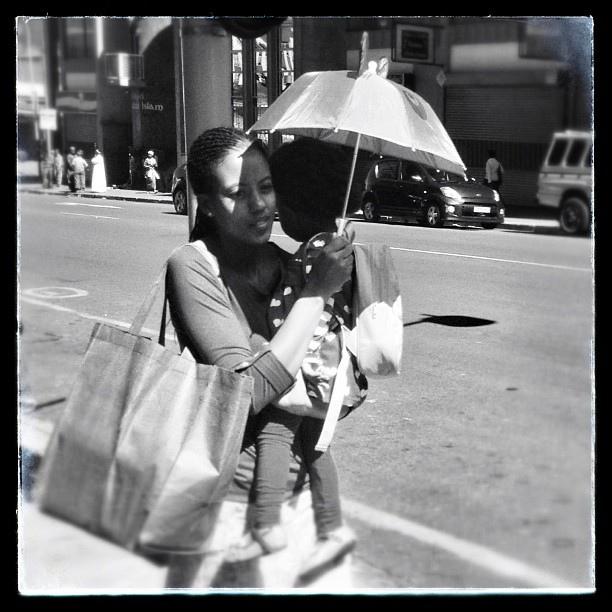Are they wearing jackets?
Short answer required. No. What is the umbrella for?
Answer briefly. Shade. Is there a drink in the woman's hand?
Give a very brief answer. No. Was this photograph taken in the past decade?
Short answer required. Yes. Is she happy?
Answer briefly. Yes. What is in the woman's arms?
Be succinct. Child. 